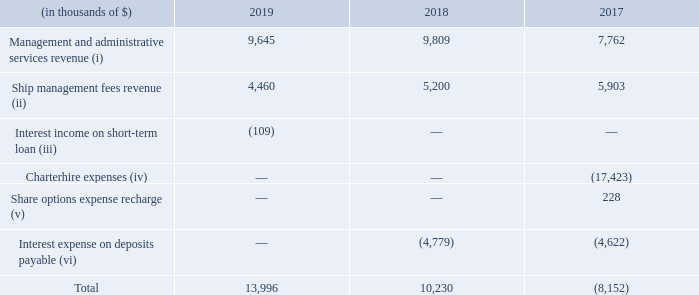25. RELATED PARTY TRANSACTIONS
a) Transactions with Golar Partners and subsidiaries:
Income (expenses):
(i) Management and administrative services revenue - On March 30, 2011, Golar Partners entered into a management and administrative services agreement with Golar Management Limited ("Golar Management"), a wholly-owned subsidiary of Golar, pursuant to which Golar Management will provide to Golar Partners certain management and administrative services. The services provided by Golar Management are charged at cost plus a management fee equal to 5% of Golar Management’s costs and expenses incurred in connection with providing these services. Golar Partners may terminate the agreement by providing 120 days written notice.
(ii) Ship management fees - Golar and certain of its affiliates charge ship management fees to Golar Partners for the provision of technical and commercial management of Golar Partners' vessels. Each of Golar Partners’ vessels is subject to management agreements pursuant to which certain commercial and technical management services are provided by Golar Management. Golar Partners may terminate these agreements by providing 30 days written notice.
(iv) Charterhire expenses - This consists of the charterhire expenses that we incurred for the charter back from Golar Partners of the Golar Grand. In connection with the sale of the Golar Grand to Golar Partners in November 2012, we issued an option where, in the event that the charterer did not renew or extend its charter for the Golar Grand beyond February 2015, the Partnership had the option to require us to charter the vessel through to October 2017. In February 2015, the option was exercised. Accordingly, we recognized charterhire costs of $17.4 million for the year ended December 31, 2017, in relation to the Golar Grand.


(iv) Charterhire expenses - This consists of the charterhire expenses that we incurred for the charter back from Golar Partners of the Golar Grand. In connection with the sale of the Golar Grand to Golar Partners in November 2012, we issued an option where, in the event that the charterer did not renew or extend its charter for the Golar Grand beyond February 2015, the Partnership had the option to require us to charter the vessel through to October 2017. In February 2015, the option was exercised. Accordingly, we recognized charterhire costs of $17.4 million for the year ended December 31, 2017, in relation to the Golar Grand.
(v) Share options expense - This relates to a recharge of share option expense to Golar Partners in relation to share options in Golar granted to certain of Golar Partners' directors, officers and employees.
(vi) Interest expense on deposits payable
Expense under Tundra Letter Agreement - In May 2016, we completed the Golar Tundra Sale and received a total cash consideration of $107.2 million. We agreed to pay Golar Partners a daily fee plus operating expenses for the right to use the Golar Tundra from the date the Golar Tundra Sale was closed, until the date that the vessel would commence operations under the Golar Tundra Time Charter. In return, Golar Partners agreed to remit to us any hire income received with respect to the Golar Tundra during that period. We have accounted for $nil, $nil and $2.2 million as interest expense for the year ended December 31, 2019, 2018 and 2017, respectively.
Deferred purchase price - In May 2017, the Golar Tundra had not commenced her charter and, accordingly, Golar Partners elected to exercise the Tundra Put Right to require us to repurchase Tundra Corp at a price equal to the original purchase price. In connection with Golar Partners exercising the Tundra Put Right, we and Golar Partners entered into an agreement pursuant to which we agreed to purchase Tundra Corp from Golar Partners on the date of the closing of the Tundra Put Sale in return we will be required to pay an amount equal to $107.2 million (the "Deferred Purchase Price") plus an additional amount equal to 5% per annum of the Deferred Purchase Price (the "Additional Amount"). The Deferred Purchase Price and the Additional Amount was applied to the net sale price of the Hilli Disposal (defined below) on July 12, 2018. We have accounted for $nil, $2.9 million and $1.1 million as interest expense for the year ended December 31, 2019, 2018 and 2017, respectively.
Deposit received from Golar Partners - On August 15, 2017, we entered into the Hilli Sale Agreement with Golar Partners for the Hilli, or the Hilli Disposal, from the Sellers of the Hilli Common Units in Hilli LLC. See note 5. Concurrent with the execution of the Hilli Sale Agreement, we received a further $70 million deposit from Golar Partners, upon which we pay interest at a rate of 5% per annum. We applied the deposit received and interest accrued to the purchase price on July 12, 2018, upon completion of the Hilli Disposal. We have accounted for $nil, $1.9 million and $1.3 million, as interest expense for the year ended December 31, 2019, 2018 and 2017, respectively.
In which years are the income(expenses) recorded for? 2019, 2018, 2017. When did Golar Partners enter into an agreement with Golar Management? March 30, 2011. How much cash consideration was received from the sale of Golar Tundra? $107.2 million. Which year was the management and administrative services revenue the highest? 9,809 > 9,645 > 7,762
Answer: 2018. What was the change in ship management fees revenue from 2017 to 2018?
Answer scale should be: thousand. 5,200 - 5,903 
Answer: -703. What was the percentage change in total from 2018 to 2019?
Answer scale should be: percent. (13,996 - 10,230)/10,230 
Answer: 36.81. 